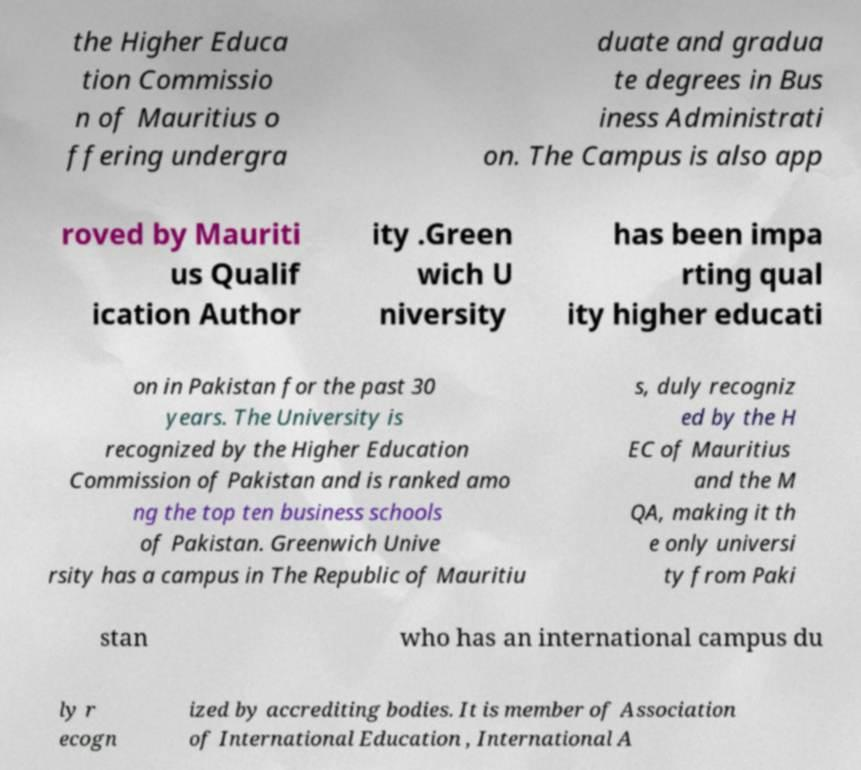Please identify and transcribe the text found in this image. the Higher Educa tion Commissio n of Mauritius o ffering undergra duate and gradua te degrees in Bus iness Administrati on. The Campus is also app roved by Mauriti us Qualif ication Author ity .Green wich U niversity has been impa rting qual ity higher educati on in Pakistan for the past 30 years. The University is recognized by the Higher Education Commission of Pakistan and is ranked amo ng the top ten business schools of Pakistan. Greenwich Unive rsity has a campus in The Republic of Mauritiu s, duly recogniz ed by the H EC of Mauritius and the M QA, making it th e only universi ty from Paki stan who has an international campus du ly r ecogn ized by accrediting bodies. It is member of Association of International Education , International A 